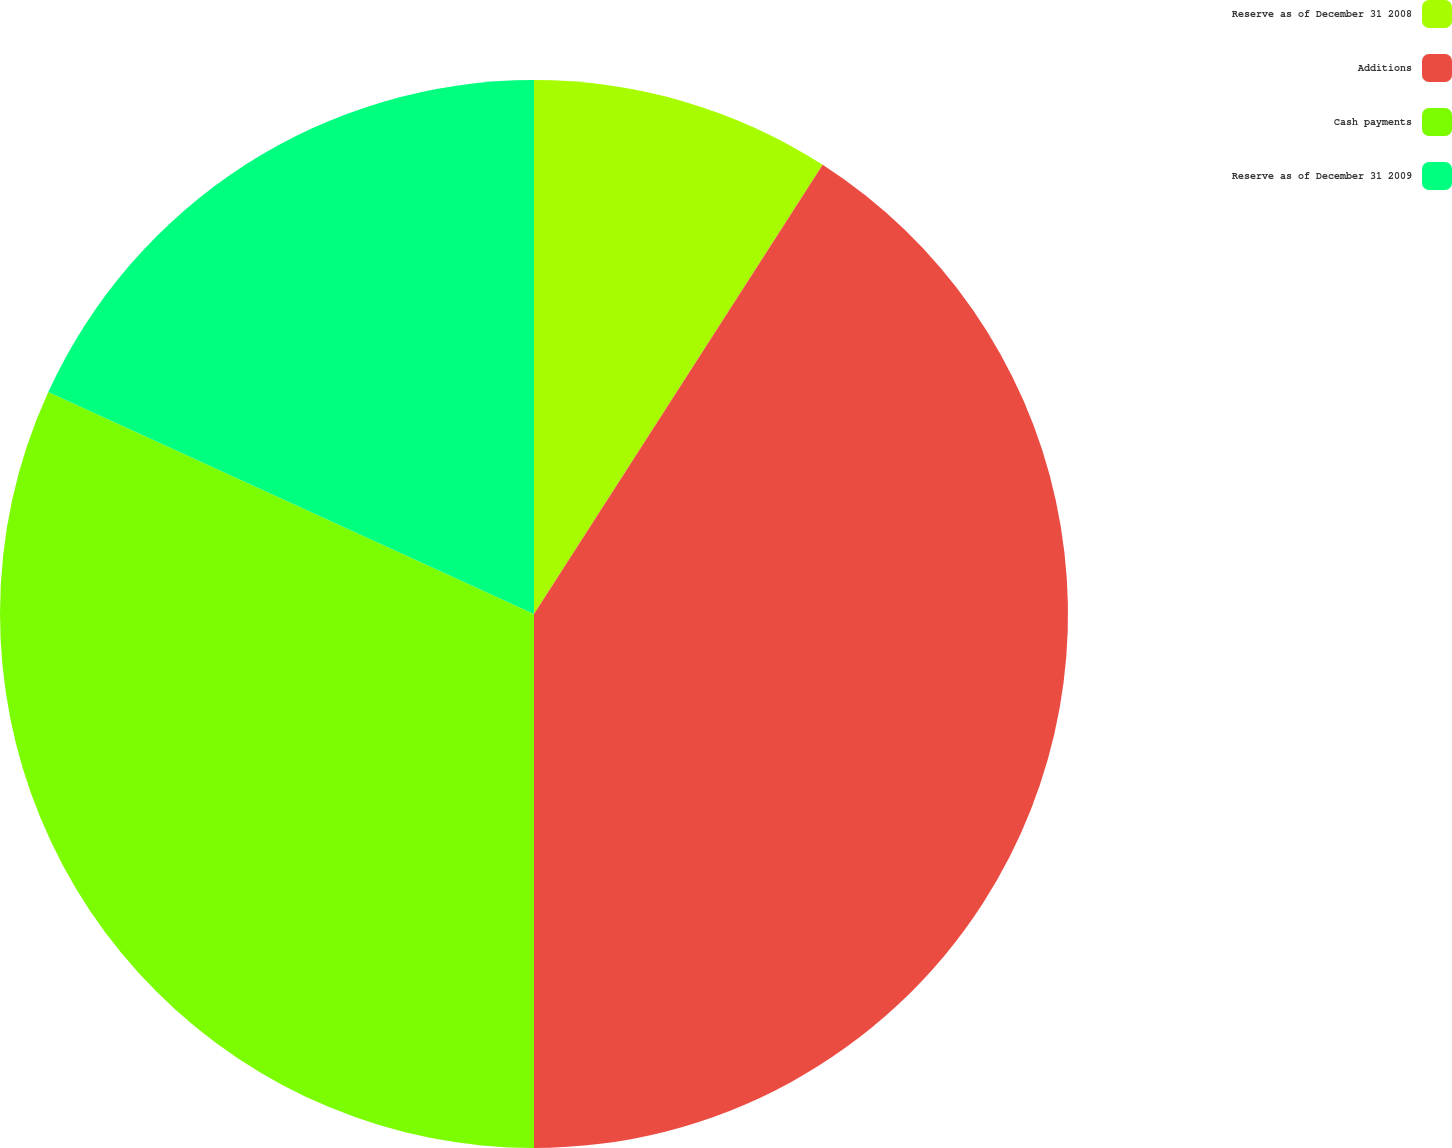Convert chart to OTSL. <chart><loc_0><loc_0><loc_500><loc_500><pie_chart><fcel>Reserve as of December 31 2008<fcel>Additions<fcel>Cash payments<fcel>Reserve as of December 31 2009<nl><fcel>9.09%<fcel>40.91%<fcel>31.82%<fcel>18.18%<nl></chart> 